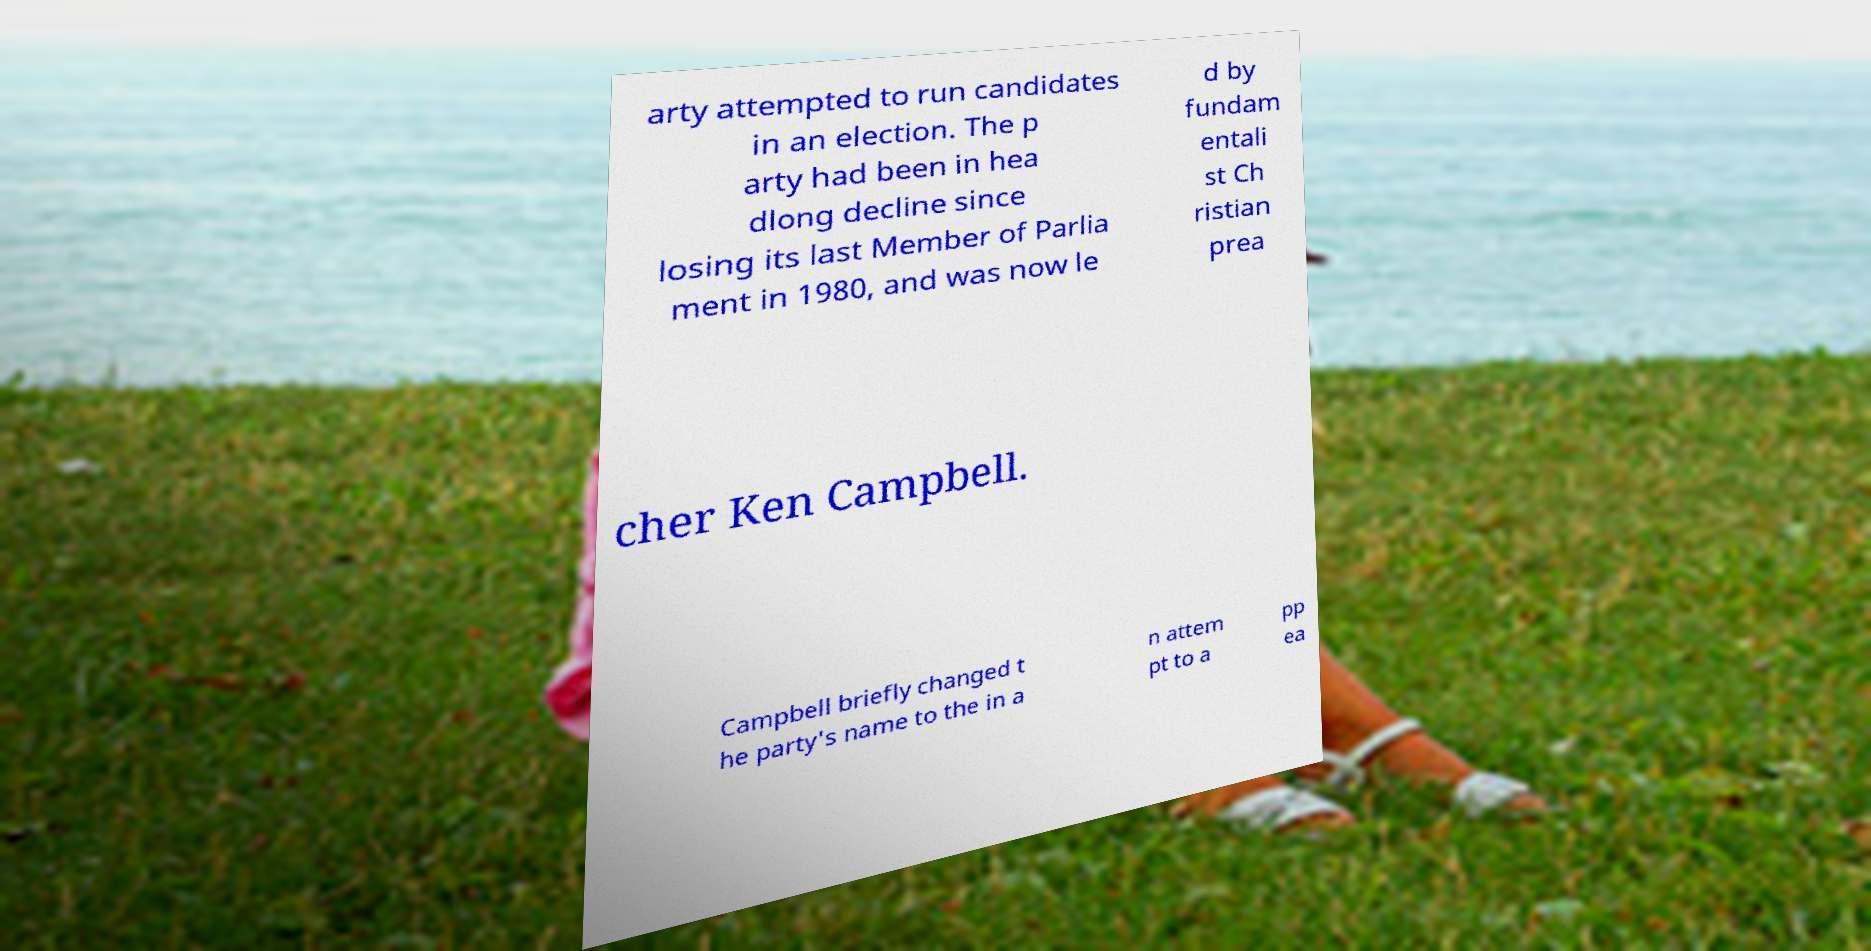Can you accurately transcribe the text from the provided image for me? arty attempted to run candidates in an election. The p arty had been in hea dlong decline since losing its last Member of Parlia ment in 1980, and was now le d by fundam entali st Ch ristian prea cher Ken Campbell. Campbell briefly changed t he party's name to the in a n attem pt to a pp ea 